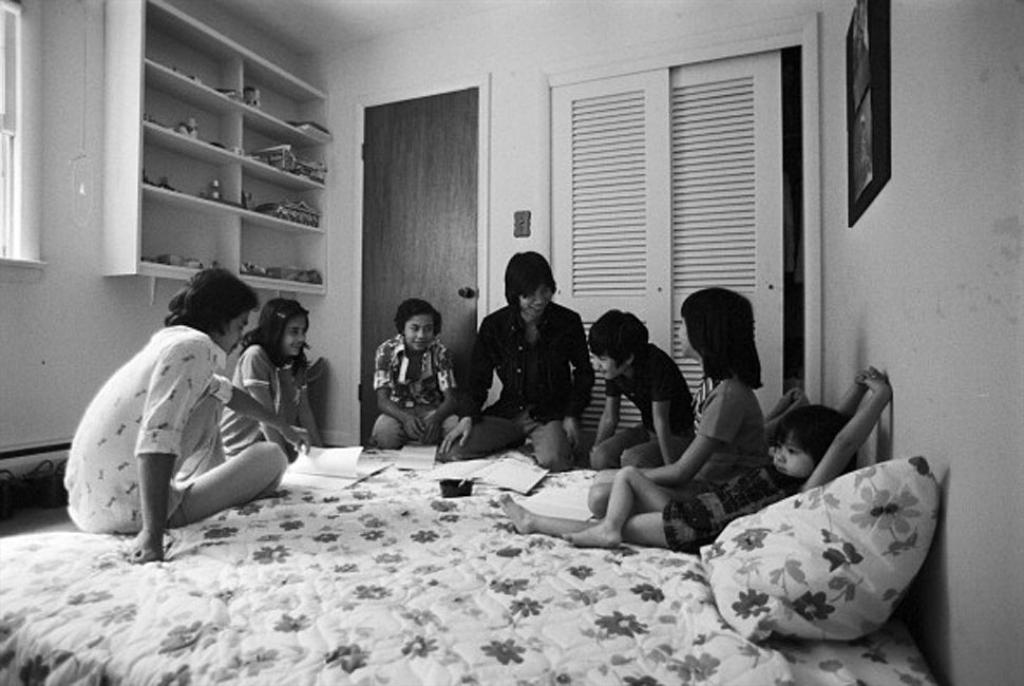What are the people in the image doing? There is a group of people sitting on a bed in the image. What other furniture or objects can be seen in the image? There is a cupboard, a door, and a shelf on the wall in the image. How many clovers are on the shelf in the image? There are no clovers present in the image; the shelf contains other items or is empty. 